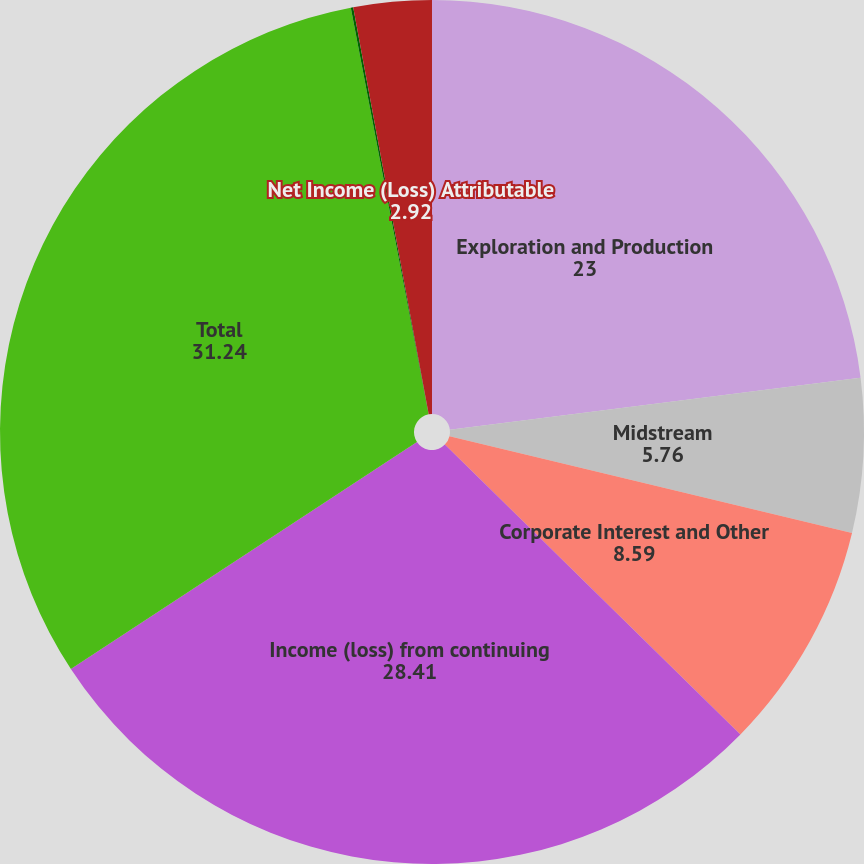Convert chart to OTSL. <chart><loc_0><loc_0><loc_500><loc_500><pie_chart><fcel>Exploration and Production<fcel>Midstream<fcel>Corporate Interest and Other<fcel>Income (loss) from continuing<fcel>Total<fcel>Continuing operations<fcel>Net Income (Loss) Attributable<nl><fcel>23.0%<fcel>5.76%<fcel>8.59%<fcel>28.41%<fcel>31.24%<fcel>0.09%<fcel>2.92%<nl></chart> 